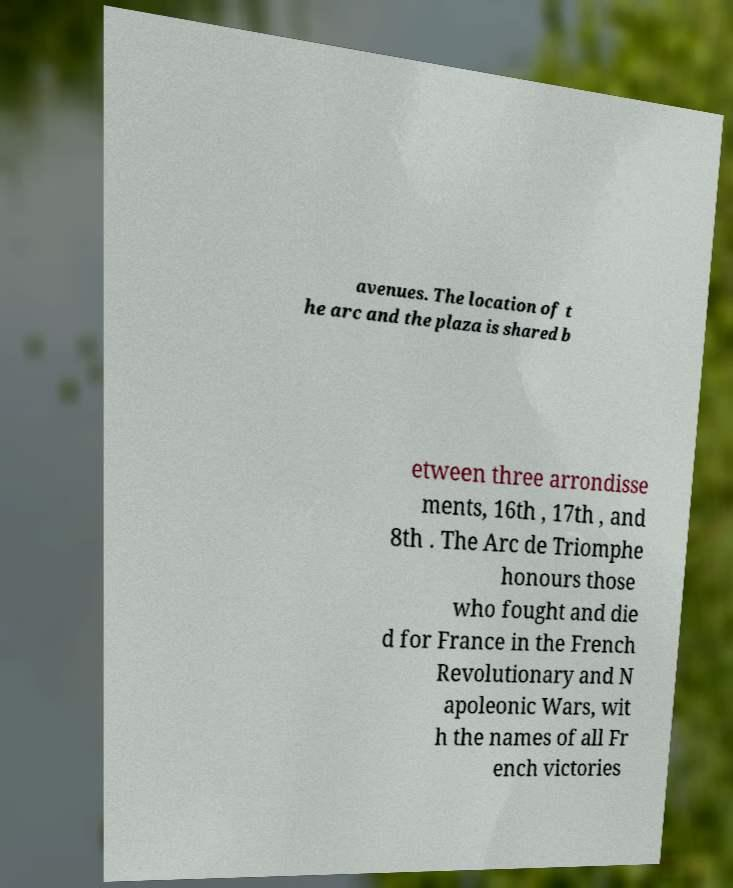Please identify and transcribe the text found in this image. avenues. The location of t he arc and the plaza is shared b etween three arrondisse ments, 16th , 17th , and 8th . The Arc de Triomphe honours those who fought and die d for France in the French Revolutionary and N apoleonic Wars, wit h the names of all Fr ench victories 